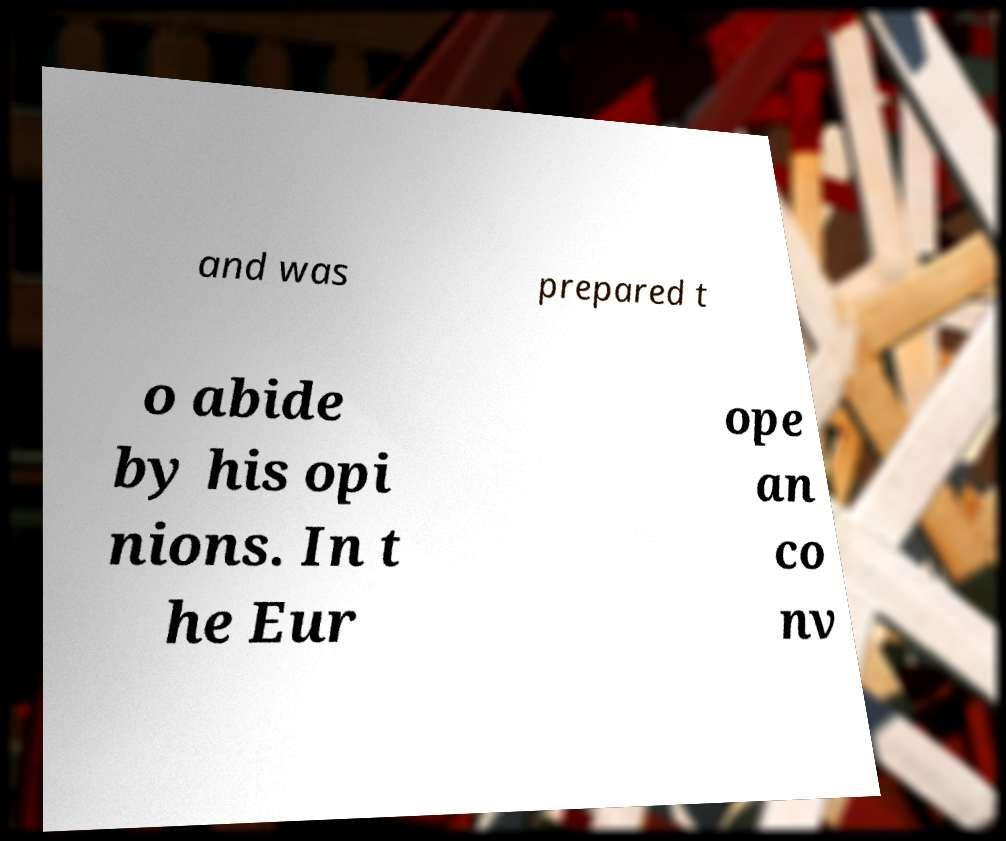I need the written content from this picture converted into text. Can you do that? and was prepared t o abide by his opi nions. In t he Eur ope an co nv 